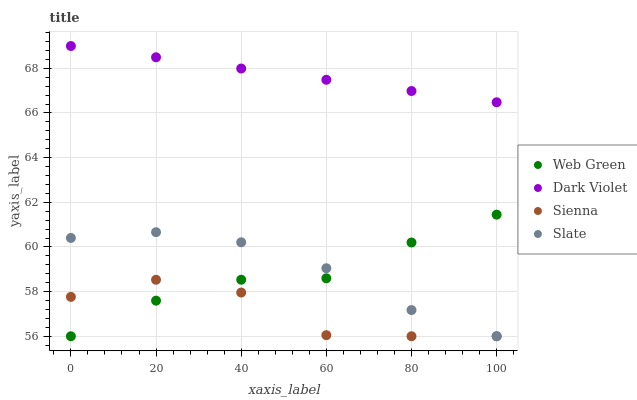Does Sienna have the minimum area under the curve?
Answer yes or no. Yes. Does Dark Violet have the maximum area under the curve?
Answer yes or no. Yes. Does Slate have the minimum area under the curve?
Answer yes or no. No. Does Slate have the maximum area under the curve?
Answer yes or no. No. Is Dark Violet the smoothest?
Answer yes or no. Yes. Is Sienna the roughest?
Answer yes or no. Yes. Is Slate the smoothest?
Answer yes or no. No. Is Slate the roughest?
Answer yes or no. No. Does Sienna have the lowest value?
Answer yes or no. Yes. Does Dark Violet have the lowest value?
Answer yes or no. No. Does Dark Violet have the highest value?
Answer yes or no. Yes. Does Slate have the highest value?
Answer yes or no. No. Is Sienna less than Dark Violet?
Answer yes or no. Yes. Is Dark Violet greater than Sienna?
Answer yes or no. Yes. Does Sienna intersect Web Green?
Answer yes or no. Yes. Is Sienna less than Web Green?
Answer yes or no. No. Is Sienna greater than Web Green?
Answer yes or no. No. Does Sienna intersect Dark Violet?
Answer yes or no. No. 